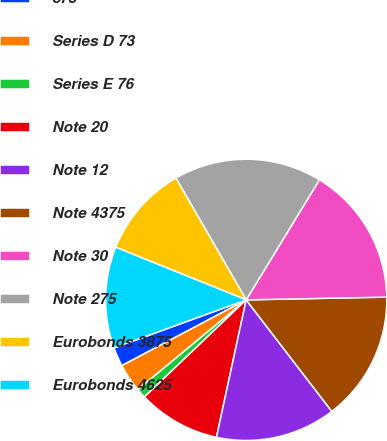Convert chart. <chart><loc_0><loc_0><loc_500><loc_500><pie_chart><fcel>875<fcel>Series D 73<fcel>Series E 76<fcel>Note 20<fcel>Note 12<fcel>Note 4375<fcel>Note 30<fcel>Note 275<fcel>Eurobonds 3875<fcel>Eurobonds 4625<nl><fcel>2.19%<fcel>3.27%<fcel>1.11%<fcel>9.49%<fcel>13.81%<fcel>14.89%<fcel>15.97%<fcel>17.05%<fcel>10.57%<fcel>11.65%<nl></chart> 